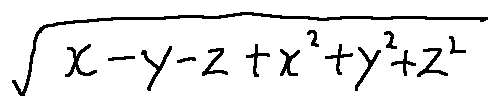Convert formula to latex. <formula><loc_0><loc_0><loc_500><loc_500>\sqrt { x - y - z + x ^ { 2 } + y ^ { 2 } + z ^ { 2 } }</formula> 